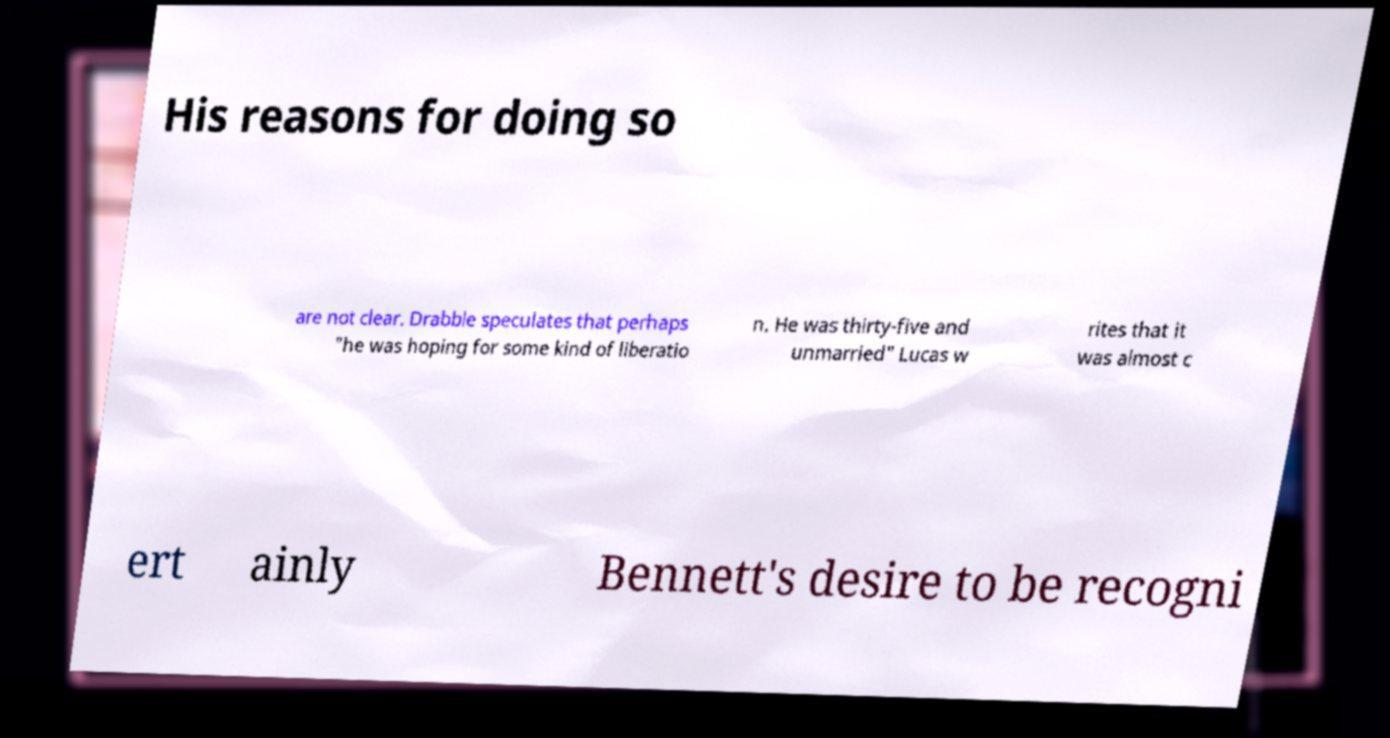Could you assist in decoding the text presented in this image and type it out clearly? His reasons for doing so are not clear. Drabble speculates that perhaps "he was hoping for some kind of liberatio n. He was thirty-five and unmarried" Lucas w rites that it was almost c ert ainly Bennett's desire to be recogni 